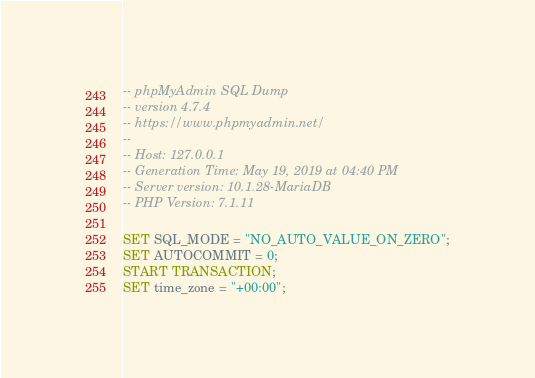<code> <loc_0><loc_0><loc_500><loc_500><_SQL_>-- phpMyAdmin SQL Dump
-- version 4.7.4
-- https://www.phpmyadmin.net/
--
-- Host: 127.0.0.1
-- Generation Time: May 19, 2019 at 04:40 PM
-- Server version: 10.1.28-MariaDB
-- PHP Version: 7.1.11

SET SQL_MODE = "NO_AUTO_VALUE_ON_ZERO";
SET AUTOCOMMIT = 0;
START TRANSACTION;
SET time_zone = "+00:00";

</code> 